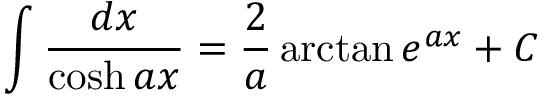Convert formula to latex. <formula><loc_0><loc_0><loc_500><loc_500>\int { \frac { d x } { \cosh a x } } = { \frac { 2 } { a } } \arctan e ^ { a x } + C</formula> 